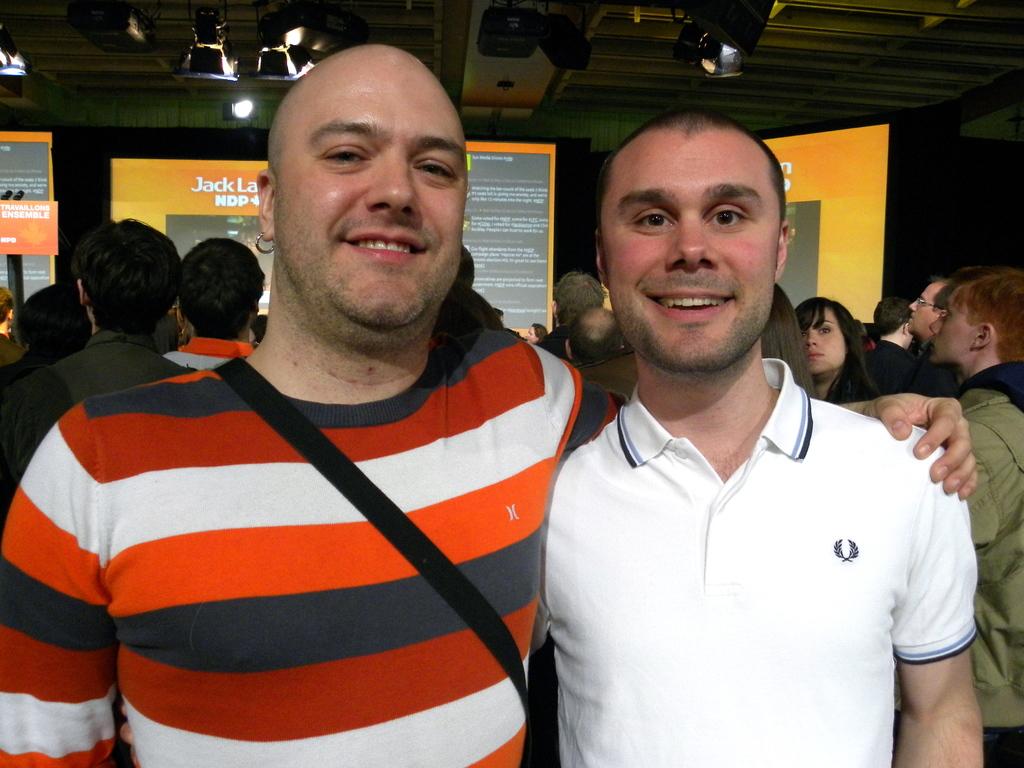What man's name is written in white on the screen in the back?
Your response must be concise. Jack. 